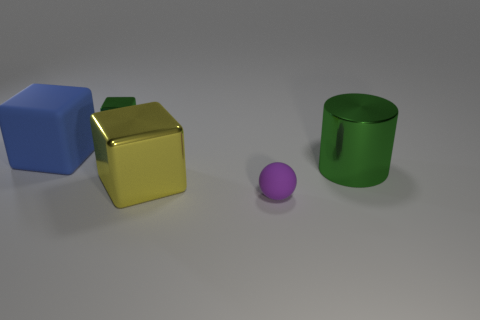Are there any tiny green blocks made of the same material as the yellow object? In the image, there are no tiny green blocks present. The objects include a blue block, a golden-yellow cube, a small purple sphere, and a green cylindrical container. However, all these objects appear to be made from a similar glossy material, possibly a type of plastic or a 3D-rendered material if the image is a digital creation. 